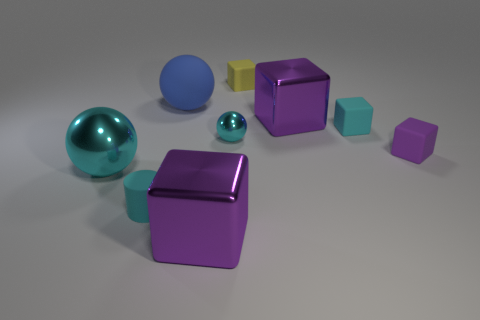If I were to categorize these objects by their edges, how would you group them? Objects in this image can be grouped based on the sharpness of their edges. The two spheres would be in one group, having no edges. The cubes, with their sharp edges, would form another group. Lastly, the octahedron, with its sharp but uniquely angled edges, would be in its own category. 